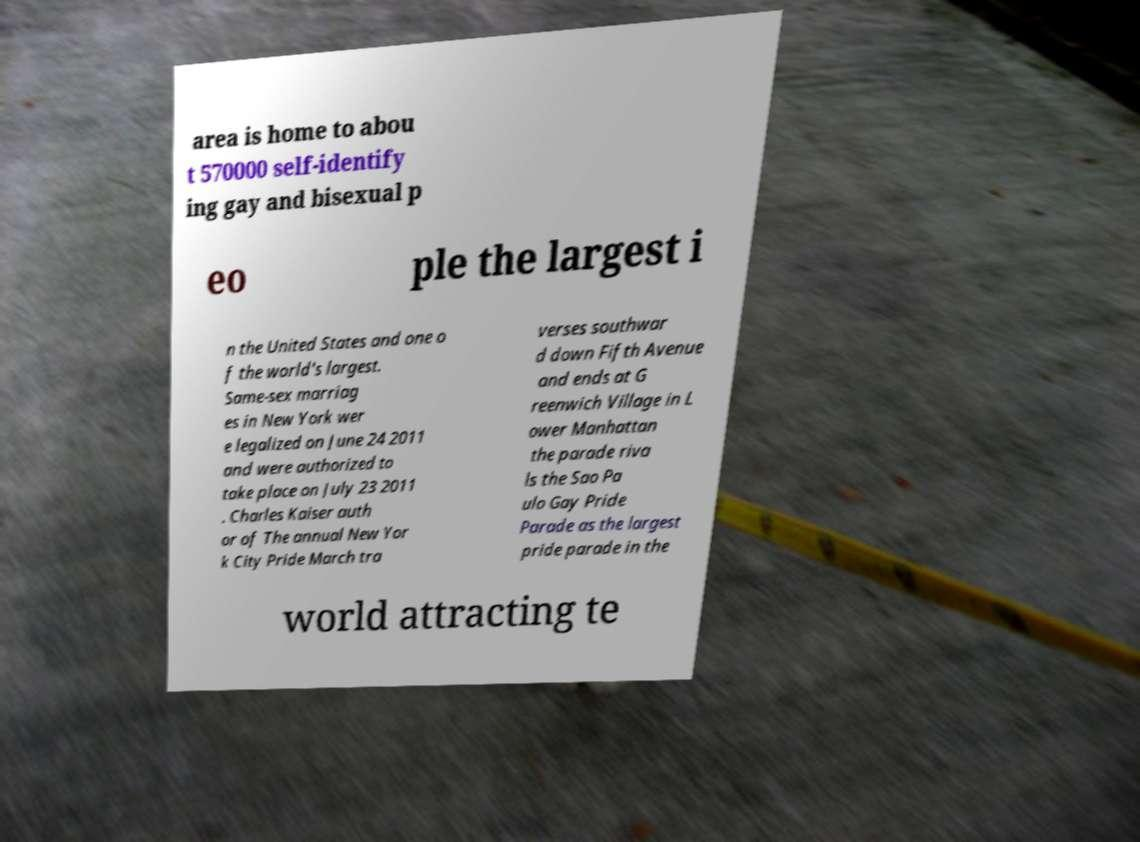There's text embedded in this image that I need extracted. Can you transcribe it verbatim? area is home to abou t 570000 self-identify ing gay and bisexual p eo ple the largest i n the United States and one o f the world's largest. Same-sex marriag es in New York wer e legalized on June 24 2011 and were authorized to take place on July 23 2011 . Charles Kaiser auth or of The annual New Yor k City Pride March tra verses southwar d down Fifth Avenue and ends at G reenwich Village in L ower Manhattan the parade riva ls the Sao Pa ulo Gay Pride Parade as the largest pride parade in the world attracting te 